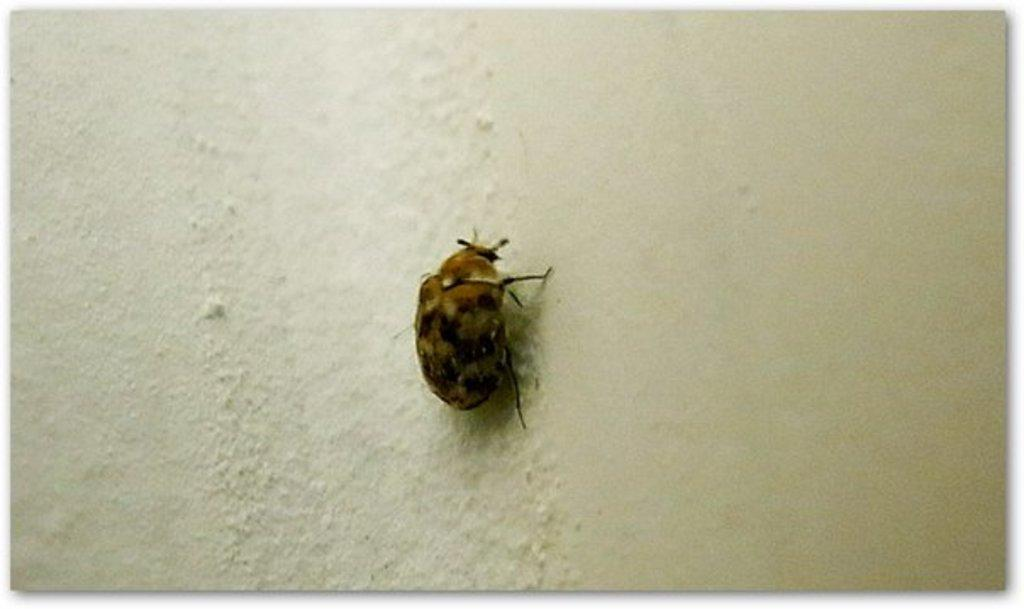What type of creature is on the wall in the image? There is a bug on the wall in the image. What type of fruit is the bug holding in the image? There is no fruit present in the image, and the bug is not holding anything. Can you see a kitty playing with the bug in the image? There is no kitty present in the image, and the bug is not interacting with any other creatures. 